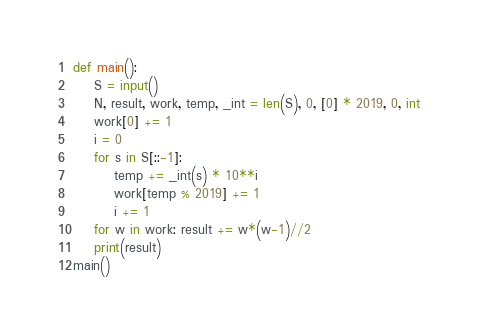<code> <loc_0><loc_0><loc_500><loc_500><_Python_>def main():
    S = input()
    N, result, work, temp, _int = len(S), 0, [0] * 2019, 0, int
    work[0] += 1
    i = 0
    for s in S[::-1]:
        temp += _int(s) * 10**i
        work[temp % 2019] += 1
        i += 1
    for w in work: result += w*(w-1)//2
    print(result)
main()</code> 